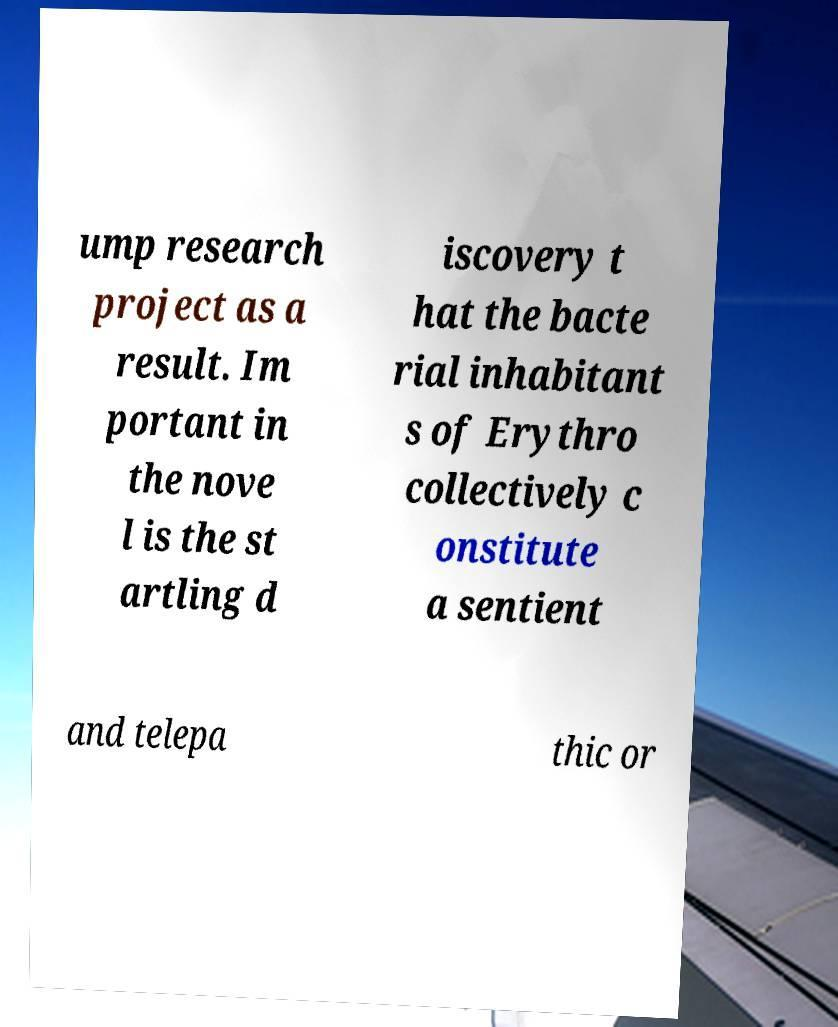Please read and relay the text visible in this image. What does it say? ump research project as a result. Im portant in the nove l is the st artling d iscovery t hat the bacte rial inhabitant s of Erythro collectively c onstitute a sentient and telepa thic or 